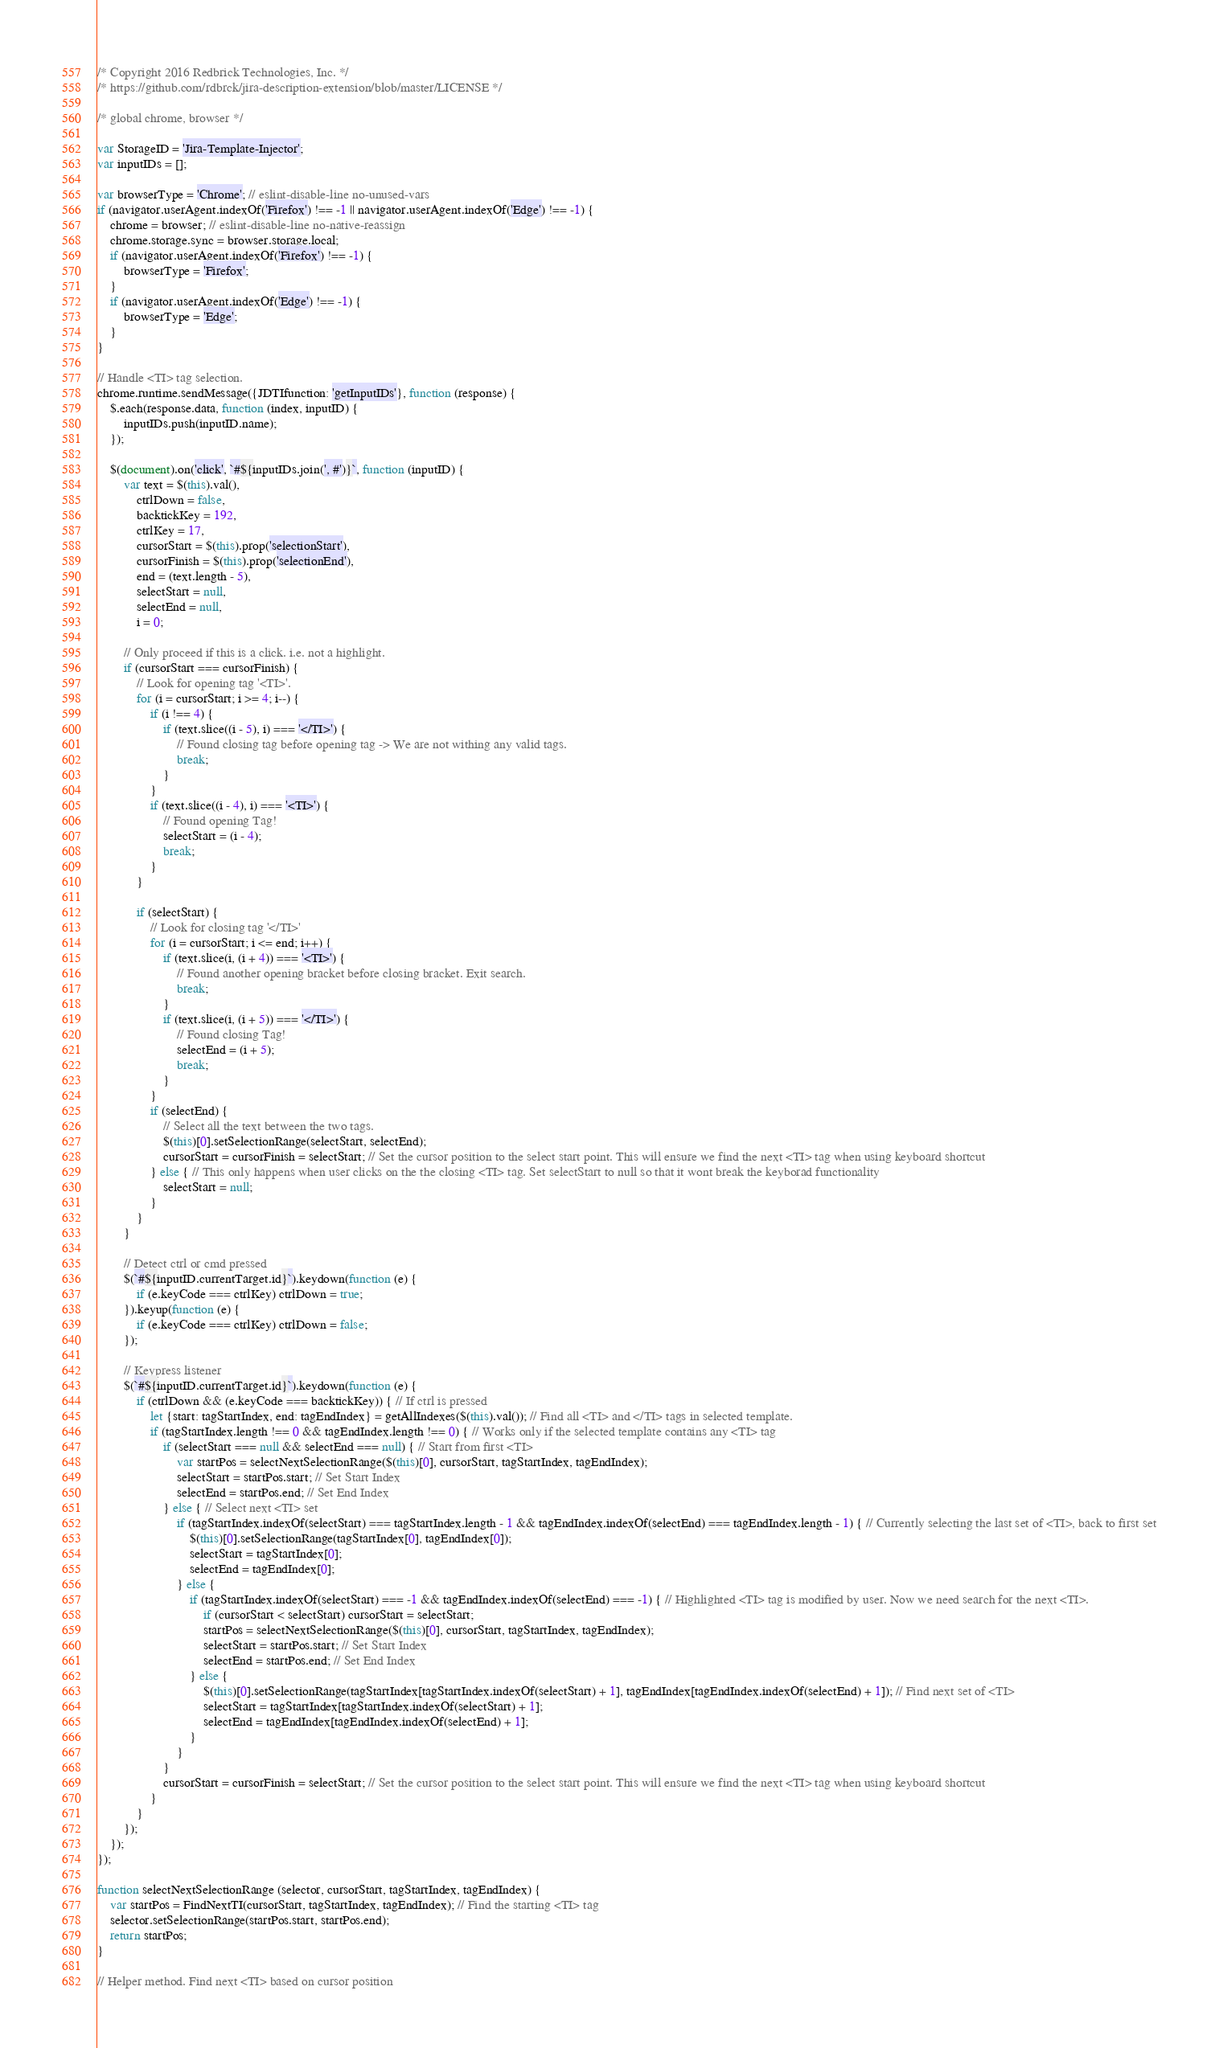Convert code to text. <code><loc_0><loc_0><loc_500><loc_500><_JavaScript_>/* Copyright 2016 Redbrick Technologies, Inc. */
/* https://github.com/rdbrck/jira-description-extension/blob/master/LICENSE */

/* global chrome, browser */

var StorageID = 'Jira-Template-Injector';
var inputIDs = [];

var browserType = 'Chrome'; // eslint-disable-line no-unused-vars
if (navigator.userAgent.indexOf('Firefox') !== -1 || navigator.userAgent.indexOf('Edge') !== -1) {
    chrome = browser; // eslint-disable-line no-native-reassign
    chrome.storage.sync = browser.storage.local;
    if (navigator.userAgent.indexOf('Firefox') !== -1) {
        browserType = 'Firefox';
    }
    if (navigator.userAgent.indexOf('Edge') !== -1) {
        browserType = 'Edge';
    }
}

// Handle <TI> tag selection.
chrome.runtime.sendMessage({JDTIfunction: 'getInputIDs'}, function (response) {
    $.each(response.data, function (index, inputID) {
        inputIDs.push(inputID.name);
    });

    $(document).on('click', `#${inputIDs.join(', #')}`, function (inputID) {
        var text = $(this).val(),
            ctrlDown = false,
            backtickKey = 192,
            ctrlKey = 17,
            cursorStart = $(this).prop('selectionStart'),
            cursorFinish = $(this).prop('selectionEnd'),
            end = (text.length - 5),
            selectStart = null,
            selectEnd = null,
            i = 0;

        // Only proceed if this is a click. i.e. not a highlight.
        if (cursorStart === cursorFinish) {
            // Look for opening tag '<TI>'.
            for (i = cursorStart; i >= 4; i--) {
                if (i !== 4) {
                    if (text.slice((i - 5), i) === '</TI>') {
                        // Found closing tag before opening tag -> We are not withing any valid tags.
                        break;
                    }
                }
                if (text.slice((i - 4), i) === '<TI>') {
                    // Found opening Tag!
                    selectStart = (i - 4);
                    break;
                }
            }

            if (selectStart) {
                // Look for closing tag '</TI>'
                for (i = cursorStart; i <= end; i++) {
                    if (text.slice(i, (i + 4)) === '<TI>') {
                        // Found another opening bracket before closing bracket. Exit search.
                        break;
                    }
                    if (text.slice(i, (i + 5)) === '</TI>') {
                        // Found closing Tag!
                        selectEnd = (i + 5);
                        break;
                    }
                }
                if (selectEnd) {
                    // Select all the text between the two tags.
                    $(this)[0].setSelectionRange(selectStart, selectEnd);
                    cursorStart = cursorFinish = selectStart; // Set the cursor position to the select start point. This will ensure we find the next <TI> tag when using keyboard shortcut
                } else { // This only happens when user clicks on the the closing <TI> tag. Set selectStart to null so that it wont break the keyborad functionality
                    selectStart = null;
                }
            }
        }

        // Detect ctrl or cmd pressed
        $(`#${inputID.currentTarget.id}`).keydown(function (e) {
            if (e.keyCode === ctrlKey) ctrlDown = true;
        }).keyup(function (e) {
            if (e.keyCode === ctrlKey) ctrlDown = false;
        });

        // Keypress listener
        $(`#${inputID.currentTarget.id}`).keydown(function (e) {
            if (ctrlDown && (e.keyCode === backtickKey)) { // If ctrl is pressed
                let {start: tagStartIndex, end: tagEndIndex} = getAllIndexes($(this).val()); // Find all <TI> and </TI> tags in selected template.
                if (tagStartIndex.length !== 0 && tagEndIndex.length !== 0) { // Works only if the selected template contains any <TI> tag
                    if (selectStart === null && selectEnd === null) { // Start from first <TI>
                        var startPos = selectNextSelectionRange($(this)[0], cursorStart, tagStartIndex, tagEndIndex);
                        selectStart = startPos.start; // Set Start Index
                        selectEnd = startPos.end; // Set End Index
                    } else { // Select next <TI> set
                        if (tagStartIndex.indexOf(selectStart) === tagStartIndex.length - 1 && tagEndIndex.indexOf(selectEnd) === tagEndIndex.length - 1) { // Currently selecting the last set of <TI>, back to first set
                            $(this)[0].setSelectionRange(tagStartIndex[0], tagEndIndex[0]);
                            selectStart = tagStartIndex[0];
                            selectEnd = tagEndIndex[0];
                        } else {
                            if (tagStartIndex.indexOf(selectStart) === -1 && tagEndIndex.indexOf(selectEnd) === -1) { // Highlighted <TI> tag is modified by user. Now we need search for the next <TI>.
                                if (cursorStart < selectStart) cursorStart = selectStart;
                                startPos = selectNextSelectionRange($(this)[0], cursorStart, tagStartIndex, tagEndIndex);
                                selectStart = startPos.start; // Set Start Index
                                selectEnd = startPos.end; // Set End Index
                            } else {
                                $(this)[0].setSelectionRange(tagStartIndex[tagStartIndex.indexOf(selectStart) + 1], tagEndIndex[tagEndIndex.indexOf(selectEnd) + 1]); // Find next set of <TI>
                                selectStart = tagStartIndex[tagStartIndex.indexOf(selectStart) + 1];
                                selectEnd = tagEndIndex[tagEndIndex.indexOf(selectEnd) + 1];
                            }
                        }
                    }
                    cursorStart = cursorFinish = selectStart; // Set the cursor position to the select start point. This will ensure we find the next <TI> tag when using keyboard shortcut
                }
            }
        });
    });
});

function selectNextSelectionRange (selector, cursorStart, tagStartIndex, tagEndIndex) {
    var startPos = FindNextTI(cursorStart, tagStartIndex, tagEndIndex); // Find the starting <TI> tag
    selector.setSelectionRange(startPos.start, startPos.end);
    return startPos;
}

// Helper method. Find next <TI> based on cursor position</code> 